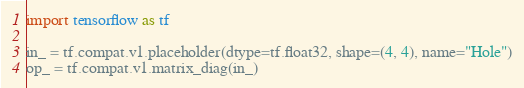<code> <loc_0><loc_0><loc_500><loc_500><_Python_>import tensorflow as tf

in_ = tf.compat.v1.placeholder(dtype=tf.float32, shape=(4, 4), name="Hole")
op_ = tf.compat.v1.matrix_diag(in_)
</code> 